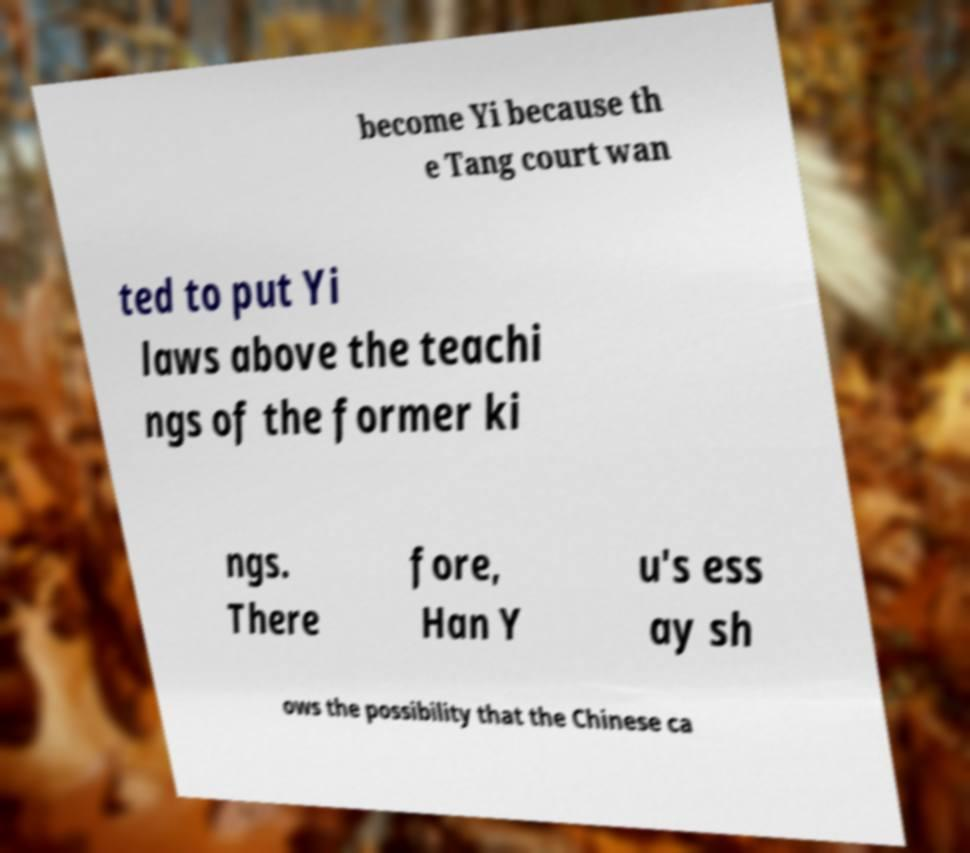For documentation purposes, I need the text within this image transcribed. Could you provide that? become Yi because th e Tang court wan ted to put Yi laws above the teachi ngs of the former ki ngs. There fore, Han Y u's ess ay sh ows the possibility that the Chinese ca 